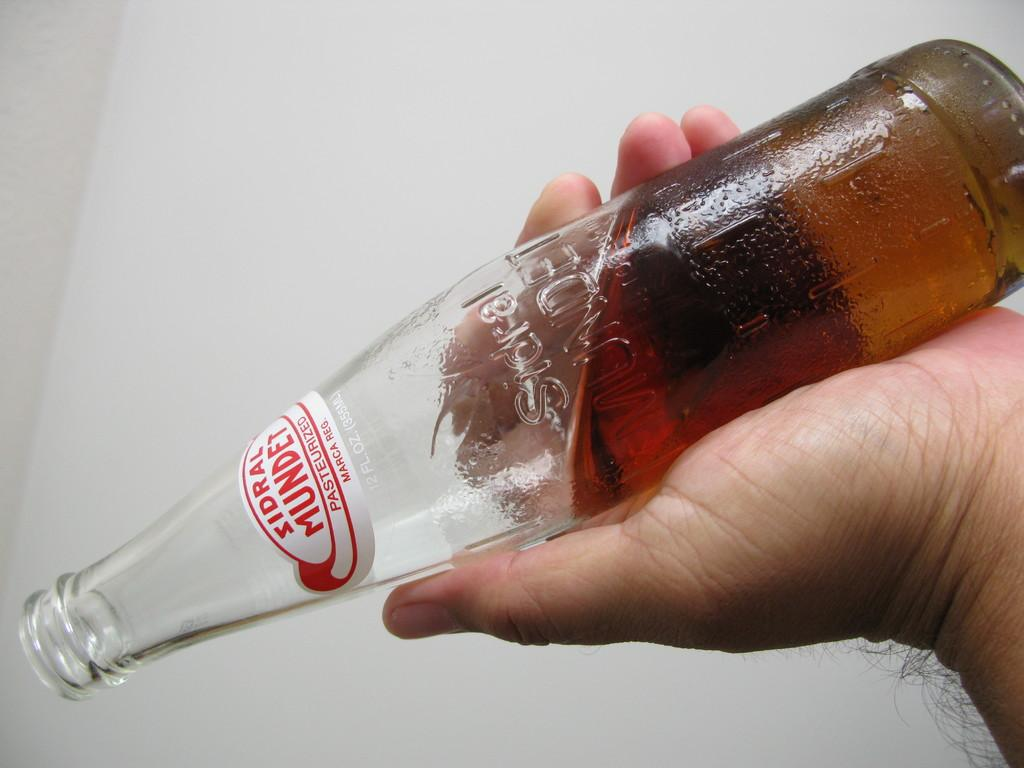<image>
Present a compact description of the photo's key features. A man is pouring out a bottle labeled Sidral Mundet 